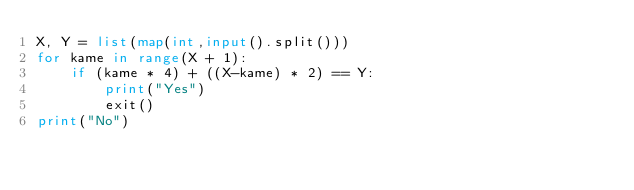Convert code to text. <code><loc_0><loc_0><loc_500><loc_500><_Python_>X, Y = list(map(int,input().split()))
for kame in range(X + 1):
    if (kame * 4) + ((X-kame) * 2) == Y:
        print("Yes")
        exit()
print("No")</code> 